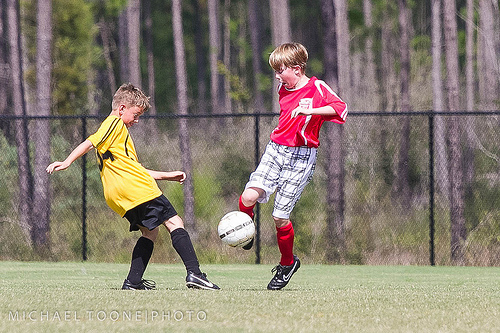<image>
Is there a ball in the boy? No. The ball is not contained within the boy. These objects have a different spatial relationship. 